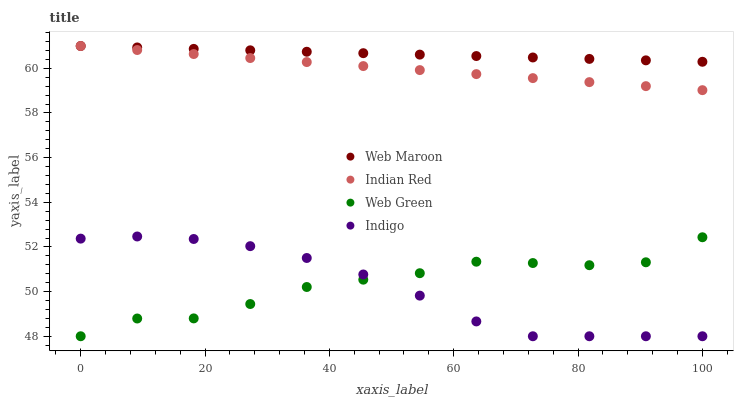Does Indigo have the minimum area under the curve?
Answer yes or no. Yes. Does Web Maroon have the maximum area under the curve?
Answer yes or no. Yes. Does Web Green have the minimum area under the curve?
Answer yes or no. No. Does Web Green have the maximum area under the curve?
Answer yes or no. No. Is Indian Red the smoothest?
Answer yes or no. Yes. Is Web Green the roughest?
Answer yes or no. Yes. Is Web Maroon the smoothest?
Answer yes or no. No. Is Web Maroon the roughest?
Answer yes or no. No. Does Indigo have the lowest value?
Answer yes or no. Yes. Does Web Maroon have the lowest value?
Answer yes or no. No. Does Indian Red have the highest value?
Answer yes or no. Yes. Does Web Green have the highest value?
Answer yes or no. No. Is Indigo less than Web Maroon?
Answer yes or no. Yes. Is Web Maroon greater than Web Green?
Answer yes or no. Yes. Does Indigo intersect Web Green?
Answer yes or no. Yes. Is Indigo less than Web Green?
Answer yes or no. No. Is Indigo greater than Web Green?
Answer yes or no. No. Does Indigo intersect Web Maroon?
Answer yes or no. No. 